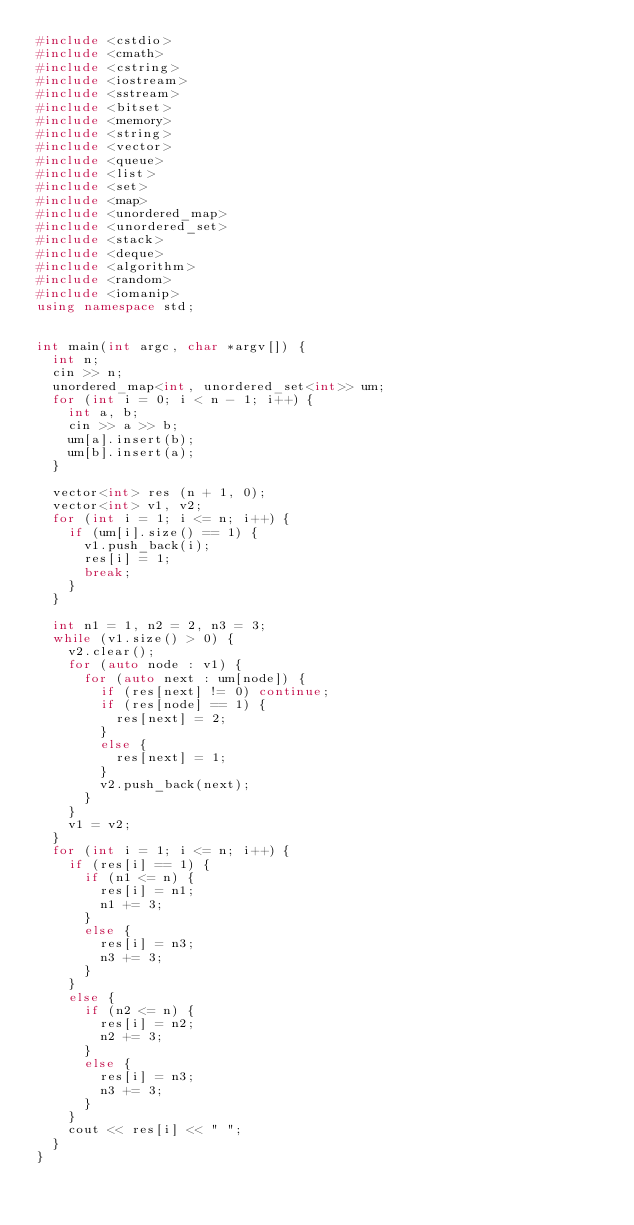<code> <loc_0><loc_0><loc_500><loc_500><_C++_>#include <cstdio>
#include <cmath>
#include <cstring>
#include <iostream>
#include <sstream>
#include <bitset>
#include <memory>
#include <string>
#include <vector>
#include <queue>
#include <list>
#include <set>
#include <map>
#include <unordered_map>
#include <unordered_set>
#include <stack>
#include <deque>
#include <algorithm>
#include <random>
#include <iomanip>
using namespace std;


int main(int argc, char *argv[]) {
	int n;
	cin >> n;
	unordered_map<int, unordered_set<int>> um;
	for (int i = 0; i < n - 1; i++) {
		int a, b;
		cin >> a >> b;
		um[a].insert(b);
		um[b].insert(a);
	}

	vector<int> res (n + 1, 0);
	vector<int> v1, v2;
	for (int i = 1; i <= n; i++) {
		if (um[i].size() == 1) {
			v1.push_back(i);
			res[i] = 1;
			break;
		}
	}

	int n1 = 1, n2 = 2, n3 = 3;
	while (v1.size() > 0) {
		v2.clear();
		for (auto node : v1) {
			for (auto next : um[node]) {
				if (res[next] != 0) continue;
				if (res[node] == 1) {
					res[next] = 2;
				}
				else {
					res[next] = 1;
				}
				v2.push_back(next);
			}
		}
		v1 = v2;
	}
	for (int i = 1; i <= n; i++) {
		if (res[i] == 1) {
			if (n1 <= n) {
				res[i] = n1;
				n1 += 3;
			}
			else {
				res[i] = n3;
				n3 += 3;
			}
		}
		else {
			if (n2 <= n) {
				res[i] = n2;
				n2 += 3;
			}
			else {
				res[i] = n3;
				n3 += 3;
			}
		}
		cout << res[i] << " ";
	}
}







</code> 